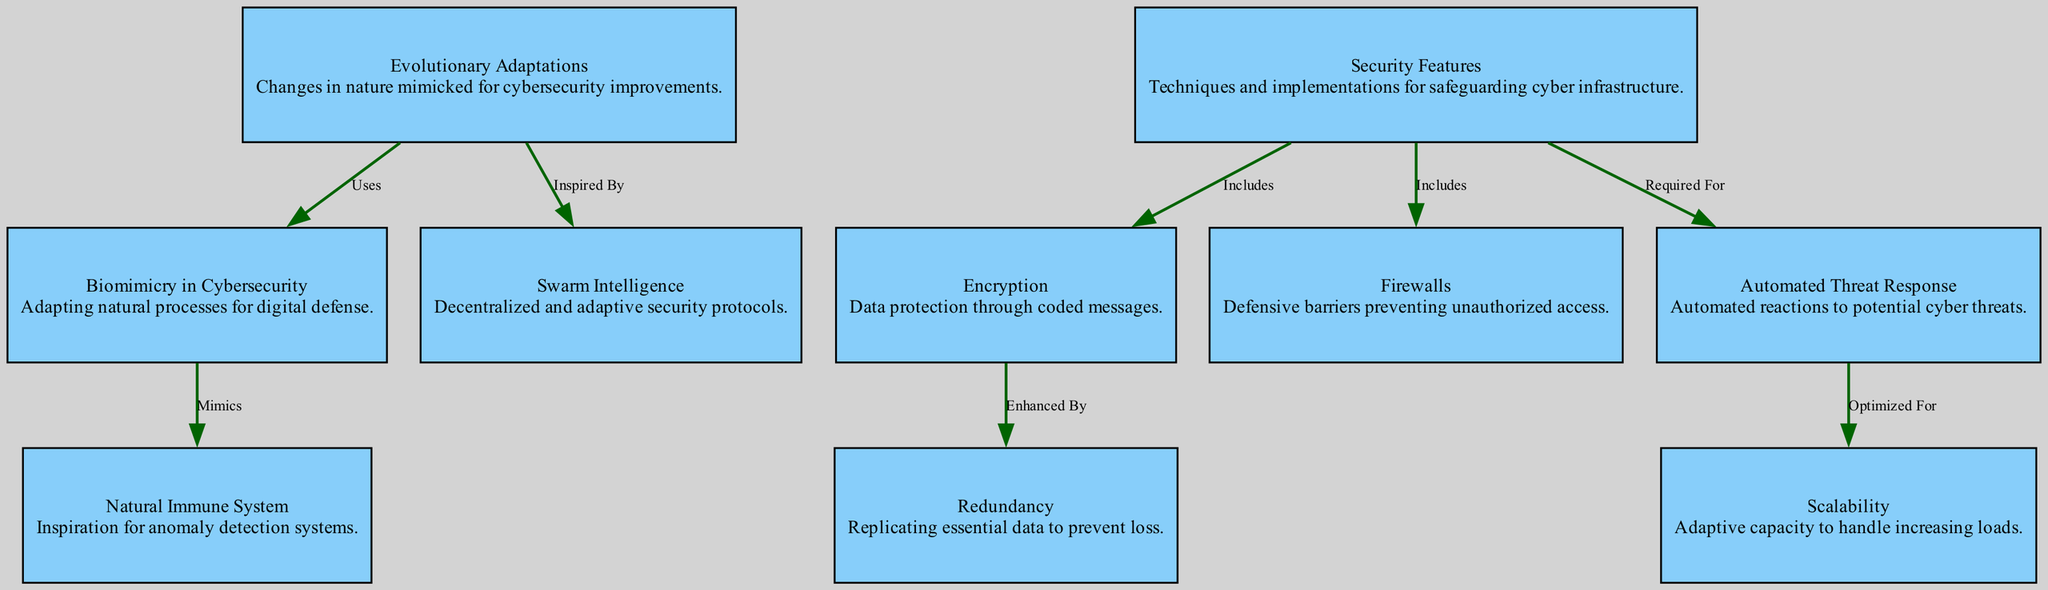What is the total number of nodes in the diagram? The diagram contains a list of nodes that are explicitly defined. By counting each unique node, we determine that there are 10 nodes present in total.
Answer: 10 Which node includes encryption as a security feature? The "Security Features" node has an edge connecting to the "Encryption" node, indicating that encryption is included within the broader category of security features.
Answer: Security Features What type of intelligence inspires decentralized security protocols in the diagram? The "Swarm Intelligence" node is directly connected to "Evolutionary Adaptations" with the label "Inspired By," showing that swarm intelligence takes inspiration from evolutionary adaptations.
Answer: Swarm Intelligence What does "Automated Threat Response" optimize for? The diagram indicates that "Automated Threat Response" is connected to "Scalability" with the label "Optimized For," meaning it is specifically designed to improve scalability within cyber infrastructure.
Answer: Scalability How does encryption enhance data protection? The edge from "Encryption" to "Redundancy" indicates that encryption is enhanced by replicating essential data, which serves to prevent data loss.
Answer: Redundancy What processes does biomimicry in cybersecurity mimic? The edge connecting "Biomimicry in Cybersecurity" to "Natural Immune System" suggests that biomimicry mimics natural immune system processes for its operations.
Answer: Natural Immune System Which security feature requires automated threat response? The diagram shows that "Automated Threat Response" is a requirement for the "Scalability" node, indicating that scalability needs automated threat response.
Answer: Scalability What type of relationships exist between evolutionary adaptations and security features? There are multiple edges connecting "Evolutionary Adaptations" to "Biomimicry in Cybersecurity" and "Swarm Intelligence," indicating that evolutionary adaptations provide foundational concepts for these specific security features.
Answer: Uses and Inspired By Which node is directly inspired by the natural immune system? The "Biomimicry in Cybersecurity" node is directly connected to the "Natural Immune System," indicating that it is inspired by this system for its security processes.
Answer: Biomimicry in Cybersecurity 